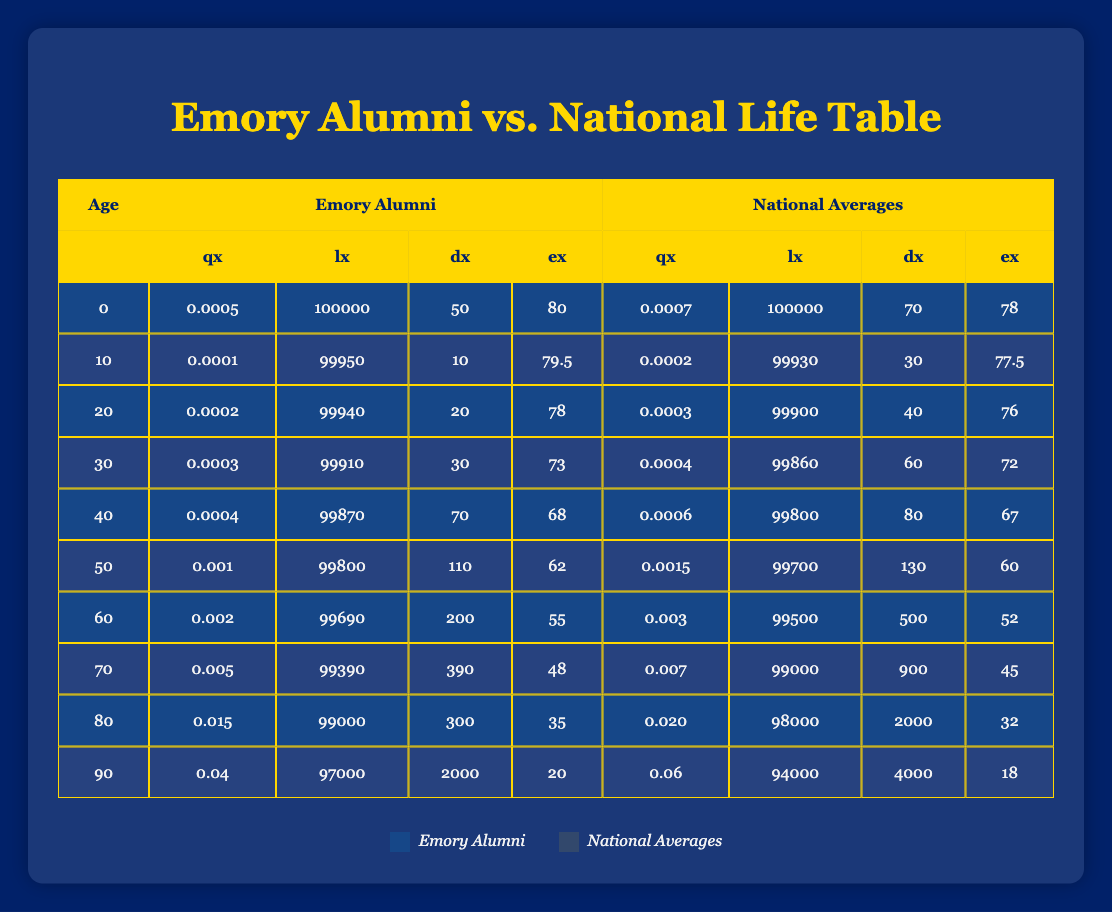What is the value of qx for Emory Alumni at age 70? The table shows data specifically for age 70 under the "Emory Alumni" section. For age 70, the corresponding qx value is 0.005.
Answer: 0.005 What is the life expectancy (ex) for the national averages at age 60? Looking at the national averages column, at age 60 the ex value is listed as 52.
Answer: 52 Is the dx value for Emory Alumni at age 80 greater than the dx value for the national averages at age 80? The dx value for Emory Alumni at age 80 is 300, while for national averages at the same age it is 2000. Since 300 is less than 2000, the statement is false.
Answer: No What is the total number of deaths (dx) for Emory Alumni between the ages of 60 and 80? From the table, the dx values for Emory Alumni from ages 60 to 80 are 200, 300. Adding these values gives 200 + 300 = 500.
Answer: 500 Which group's life expectancy (ex) is higher at age 40, Emory Alumni or national averages? The life expectancy for Emory Alumni at age 40 is 68, while the life expectancy for national averages at age 40 is 67. Since 68 is greater than 67, Emory Alumni has a higher life expectancy.
Answer: Emory Alumni What is the average qx value for the national averages across all ages listed in the table? To calculate the average, sum the qx values: (0.0007 + 0.0002 + 0.0003 + 0.0004 + 0.0006 + 0.0015 + 0.003 + 0.007 + 0.020 + 0.06) = 0.0937. Then, divide by the number of age groups, which is 10, giving 0.0937 / 10 = 0.00937.
Answer: 0.00937 Do Emory Alumni have a lower qx value compared to national averages for the age group of 50? For age 50, the qx for Emory Alumni is 0.001, while for national averages it is 0.0015. Since 0.001 is less than 0.0015, Emory Alumni do have a lower qx value.
Answer: Yes At what age does the mortality rate (qx) exceed 0.01 for Emory Alumni? In the table for Emory Alumni, the qx values for each age group do not exceed 0.01 until age 60, where qx starts to approach this value. The first occurrence over 0.01 is at age 60.
Answer: Age 60 What percentage of the original cohort (lx) remains for Emory Alumni at age 90? Starting with a cohort of 100000 at age 0, at age 90 the lx value is 94000. To find the percentage, divide 97000 by 100000 and multiply by 100, giving (97000 / 100000) * 100 = 94%.
Answer: 94% 